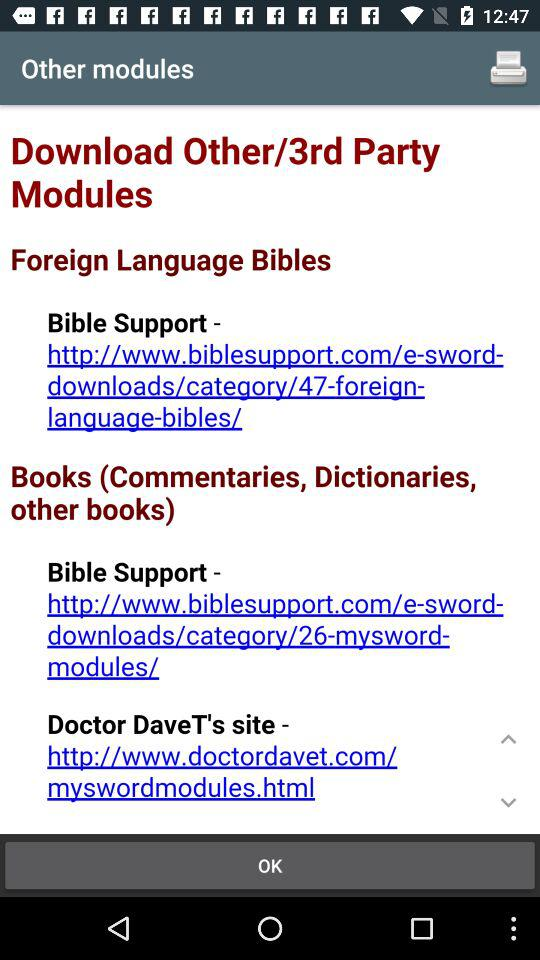What is the Doctor DaveT's site URL address? The URL address is http://www.doctordavet.com/myswordmodules.html. 